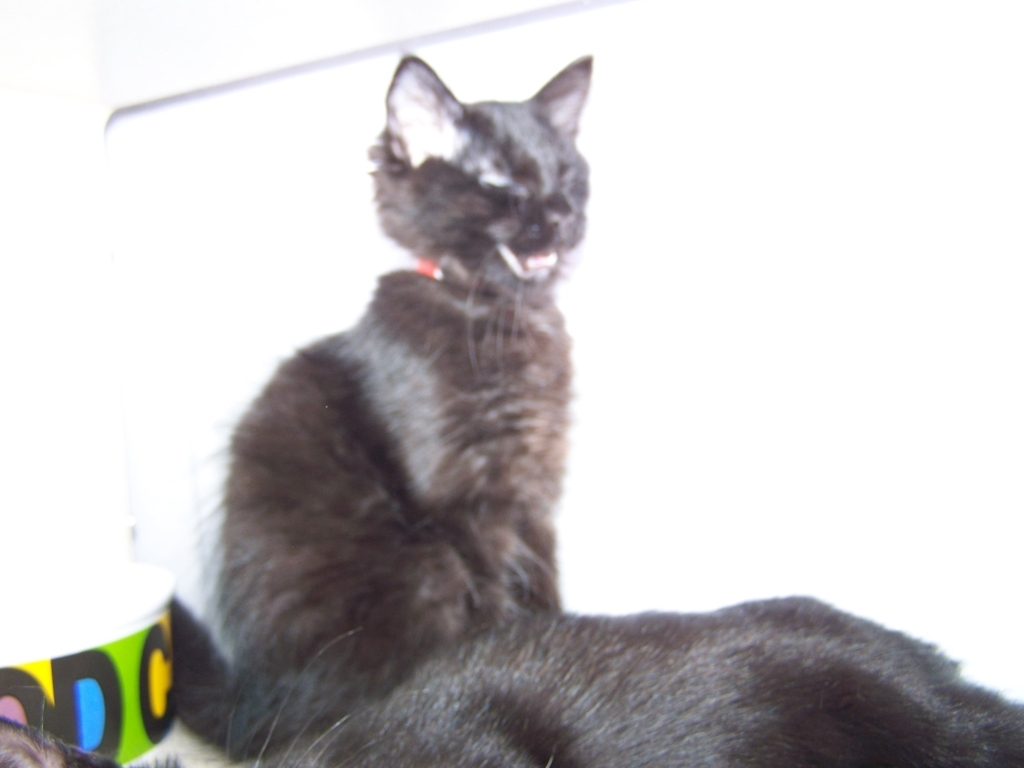Are the details of the cat clearly visible? Due to the overexposure of the image and the cat being out of focus, the details of the cat are not clearly visible. The image's brightness affects the visibility of finer details such as fur texture and facial features. 